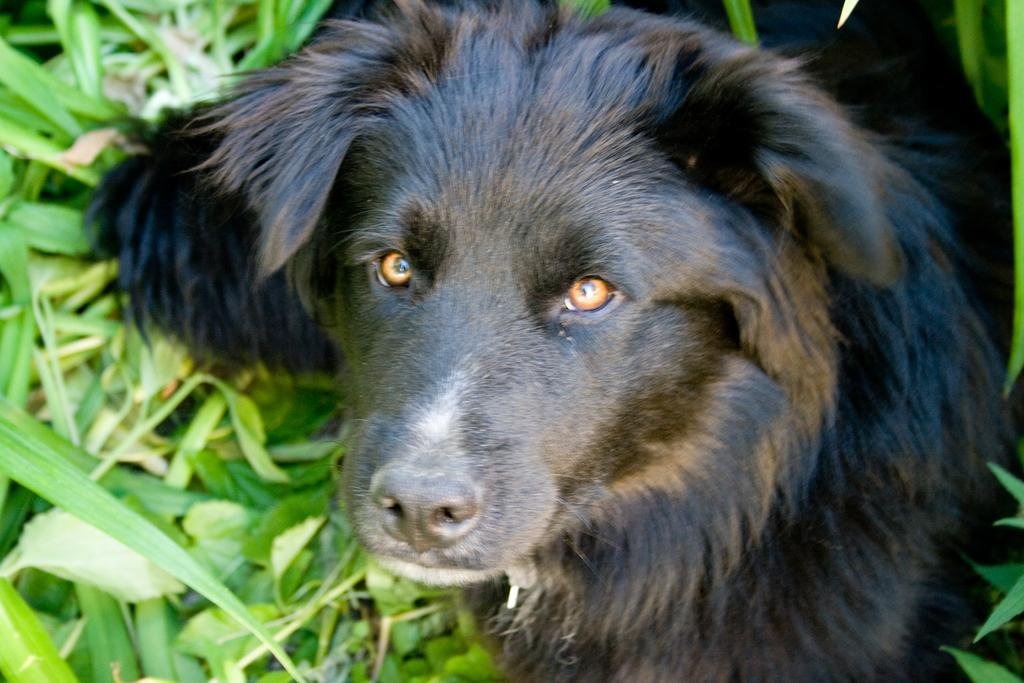What type of animal is in the image? There is a black dog in the image. What type of vegetation is present in the image? There are green leaves in the image. What type of soup is being served in the image? There is no soup present in the image; it features a black dog and green leaves. How many suns are visible in the image? There is no sun present in the image; it only features a black dog and green leaves. 